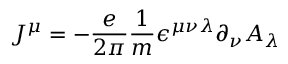Convert formula to latex. <formula><loc_0><loc_0><loc_500><loc_500>J ^ { \mu } = - { \frac { e } { 2 \pi } } { \frac { 1 } { m } } \epsilon ^ { \mu \nu \lambda } \partial _ { \nu } A _ { \lambda }</formula> 